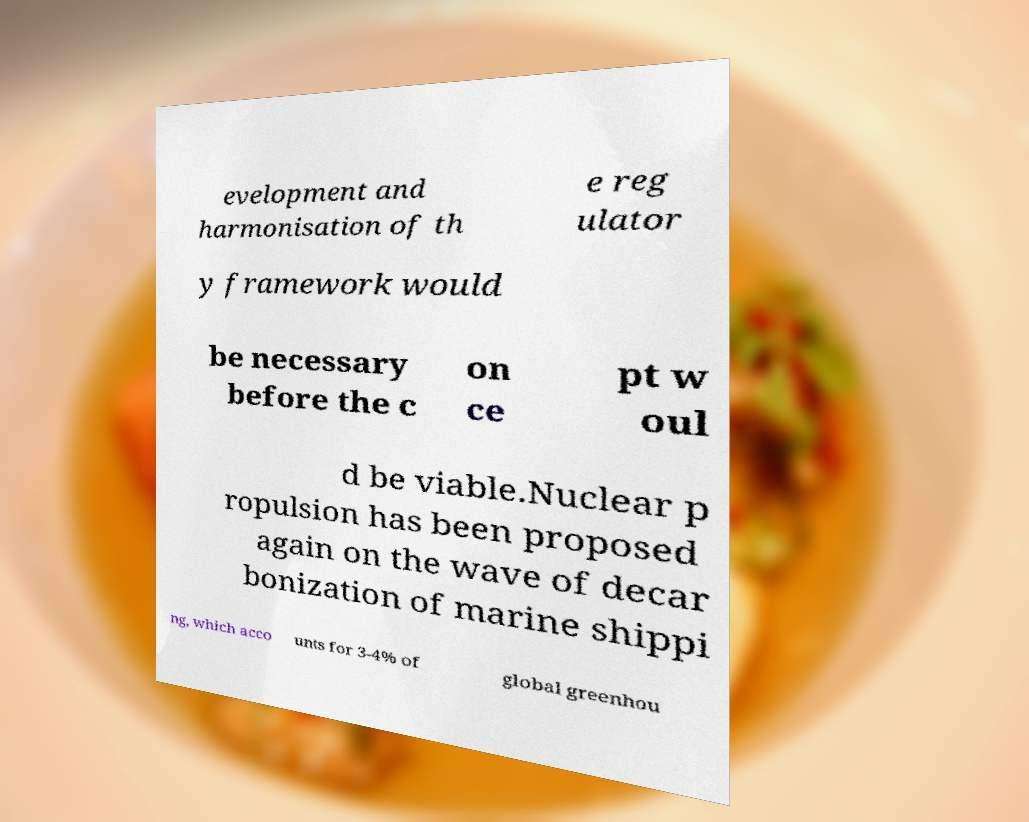Can you accurately transcribe the text from the provided image for me? evelopment and harmonisation of th e reg ulator y framework would be necessary before the c on ce pt w oul d be viable.Nuclear p ropulsion has been proposed again on the wave of decar bonization of marine shippi ng, which acco unts for 3-4% of global greenhou 